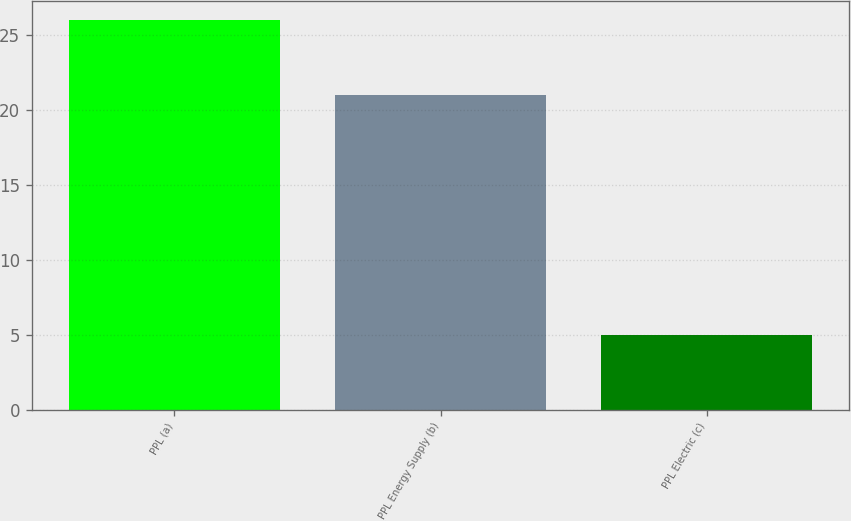Convert chart. <chart><loc_0><loc_0><loc_500><loc_500><bar_chart><fcel>PPL (a)<fcel>PPL Energy Supply (b)<fcel>PPL Electric (c)<nl><fcel>26<fcel>21<fcel>5<nl></chart> 